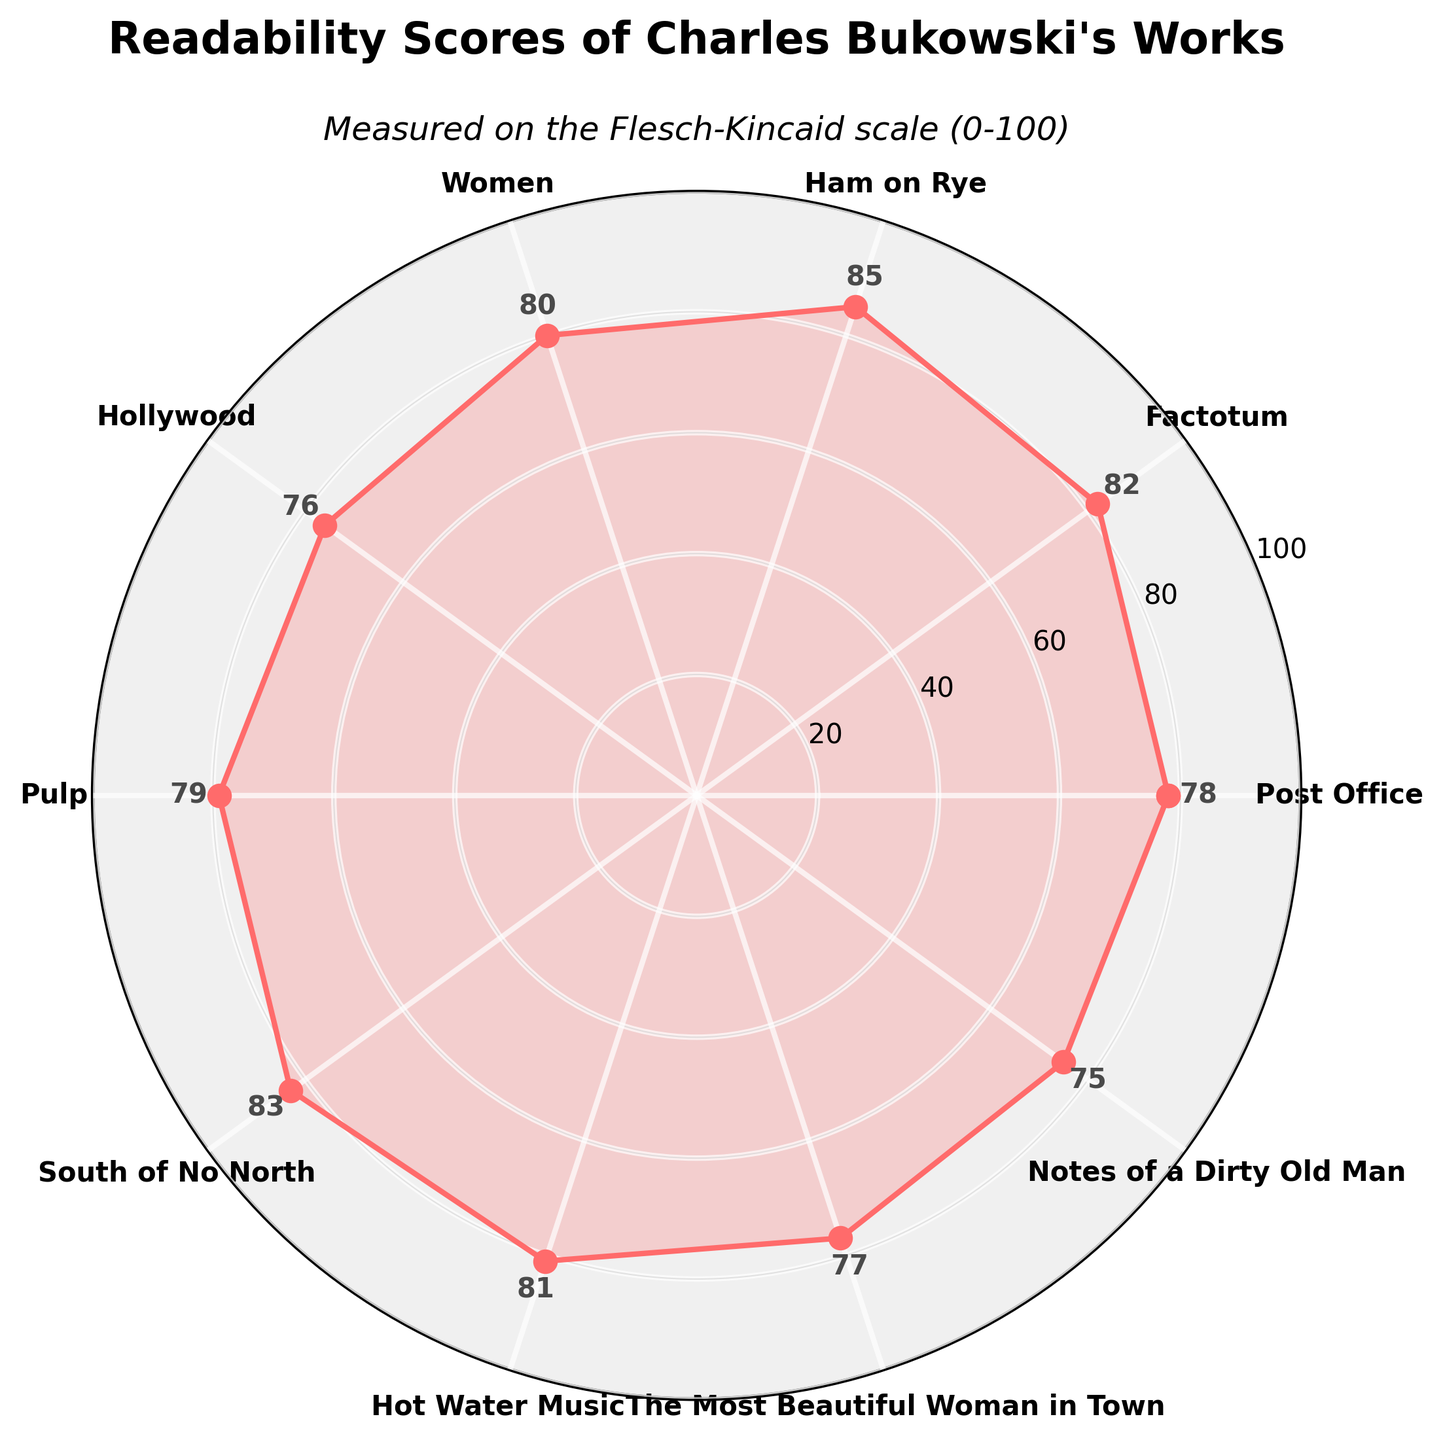What is the readability score of "Post Office"? The score for "Post Office" can be found by looking at the label on the plot. It is marked as 78.
Answer: 78 Which work has the highest readability score? By analyzing the plotted scores, "Ham on Rye" has the highest readability score of 85.
Answer: Ham on Rye How many works have a readability score above 80? Using visual inspection, the works "Factotum," "Ham on Rye," "South of No North," and "Hot Water Music" have scores above 80. This totals four works.
Answer: 4 What is the average readability score of "Hollywood," "Pulp," and "Notes of a Dirty Old Man"? The scores are 76, 79, and 75 respectively. Adding these gives 76 + 79 + 75 = 230. Dividing by 3, the average score is 230/3 = 76.67.
Answer: 76.67 Compare the readability score of "Women" and "Hot Water Music." Which is higher? The score of "Women" is 80, and the score of "Hot Water Music" is 81. Therefore, "Hot Water Music" has a higher score.
Answer: Hot Water Music What is the median readability score of Bukowski's works? To find the median, order the scores: 75, 76, 77, 78, 79, 80, 81, 82, 83, 85. The median will be the average of the 5th and 6th scores: (79 + 80)/2 = 79.5
Answer: 79.5 What is the total sum of readability scores for all the works shown? Adding all the scores: 78 + 82 + 85 + 80 + 76 + 79 + 83 + 81 + 77 + 75 = 796.
Answer: 796 Which work has the second lowest readability score? The second lowest readability score after "Notes of a Dirty Old Man" (75) is "Hollywood" with a score of 76.
Answer: Hollywood What is the range of readability scores for these works? The range is the difference between the highest score (85) and the lowest score (75). So, 85 - 75 = 10.
Answer: 10 If we categorize readability scores into 'High' (above 80) and 'Low' (80 and below), how many works fall into each category? By visual inspection, 'High' category includes "Factotum," "Ham on Rye," "South of No North," and "Hot Water Music" (4 works). The 'Low' category includes "Post Office," "Women," "Hollywood," "Pulp," "The Most Beautiful Woman in Town," and "Notes of a Dirty Old Man" (6 works).
Answer: High: 4, Low: 6 